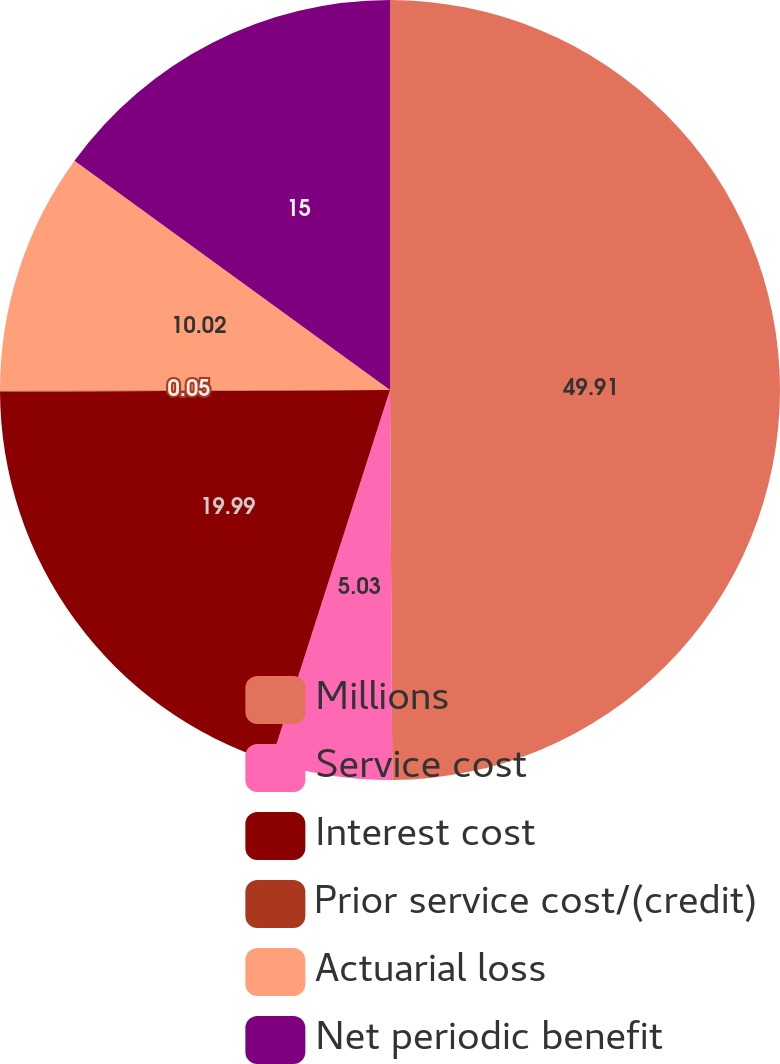Convert chart to OTSL. <chart><loc_0><loc_0><loc_500><loc_500><pie_chart><fcel>Millions<fcel>Service cost<fcel>Interest cost<fcel>Prior service cost/(credit)<fcel>Actuarial loss<fcel>Net periodic benefit<nl><fcel>49.9%<fcel>5.03%<fcel>19.99%<fcel>0.05%<fcel>10.02%<fcel>15.0%<nl></chart> 